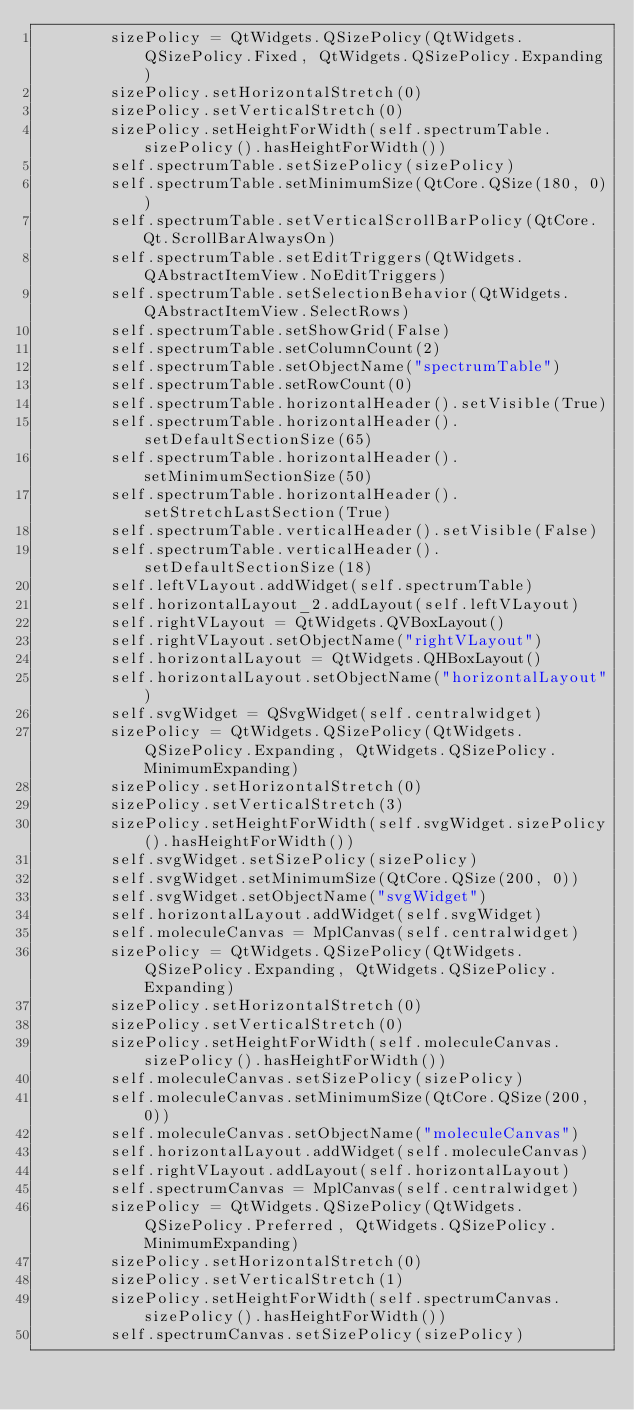Convert code to text. <code><loc_0><loc_0><loc_500><loc_500><_Python_>        sizePolicy = QtWidgets.QSizePolicy(QtWidgets.QSizePolicy.Fixed, QtWidgets.QSizePolicy.Expanding)
        sizePolicy.setHorizontalStretch(0)
        sizePolicy.setVerticalStretch(0)
        sizePolicy.setHeightForWidth(self.spectrumTable.sizePolicy().hasHeightForWidth())
        self.spectrumTable.setSizePolicy(sizePolicy)
        self.spectrumTable.setMinimumSize(QtCore.QSize(180, 0))
        self.spectrumTable.setVerticalScrollBarPolicy(QtCore.Qt.ScrollBarAlwaysOn)
        self.spectrumTable.setEditTriggers(QtWidgets.QAbstractItemView.NoEditTriggers)
        self.spectrumTable.setSelectionBehavior(QtWidgets.QAbstractItemView.SelectRows)
        self.spectrumTable.setShowGrid(False)
        self.spectrumTable.setColumnCount(2)
        self.spectrumTable.setObjectName("spectrumTable")
        self.spectrumTable.setRowCount(0)
        self.spectrumTable.horizontalHeader().setVisible(True)
        self.spectrumTable.horizontalHeader().setDefaultSectionSize(65)
        self.spectrumTable.horizontalHeader().setMinimumSectionSize(50)
        self.spectrumTable.horizontalHeader().setStretchLastSection(True)
        self.spectrumTable.verticalHeader().setVisible(False)
        self.spectrumTable.verticalHeader().setDefaultSectionSize(18)
        self.leftVLayout.addWidget(self.spectrumTable)
        self.horizontalLayout_2.addLayout(self.leftVLayout)
        self.rightVLayout = QtWidgets.QVBoxLayout()
        self.rightVLayout.setObjectName("rightVLayout")
        self.horizontalLayout = QtWidgets.QHBoxLayout()
        self.horizontalLayout.setObjectName("horizontalLayout")
        self.svgWidget = QSvgWidget(self.centralwidget)
        sizePolicy = QtWidgets.QSizePolicy(QtWidgets.QSizePolicy.Expanding, QtWidgets.QSizePolicy.MinimumExpanding)
        sizePolicy.setHorizontalStretch(0)
        sizePolicy.setVerticalStretch(3)
        sizePolicy.setHeightForWidth(self.svgWidget.sizePolicy().hasHeightForWidth())
        self.svgWidget.setSizePolicy(sizePolicy)
        self.svgWidget.setMinimumSize(QtCore.QSize(200, 0))
        self.svgWidget.setObjectName("svgWidget")
        self.horizontalLayout.addWidget(self.svgWidget)
        self.moleculeCanvas = MplCanvas(self.centralwidget)
        sizePolicy = QtWidgets.QSizePolicy(QtWidgets.QSizePolicy.Expanding, QtWidgets.QSizePolicy.Expanding)
        sizePolicy.setHorizontalStretch(0)
        sizePolicy.setVerticalStretch(0)
        sizePolicy.setHeightForWidth(self.moleculeCanvas.sizePolicy().hasHeightForWidth())
        self.moleculeCanvas.setSizePolicy(sizePolicy)
        self.moleculeCanvas.setMinimumSize(QtCore.QSize(200, 0))
        self.moleculeCanvas.setObjectName("moleculeCanvas")
        self.horizontalLayout.addWidget(self.moleculeCanvas)
        self.rightVLayout.addLayout(self.horizontalLayout)
        self.spectrumCanvas = MplCanvas(self.centralwidget)
        sizePolicy = QtWidgets.QSizePolicy(QtWidgets.QSizePolicy.Preferred, QtWidgets.QSizePolicy.MinimumExpanding)
        sizePolicy.setHorizontalStretch(0)
        sizePolicy.setVerticalStretch(1)
        sizePolicy.setHeightForWidth(self.spectrumCanvas.sizePolicy().hasHeightForWidth())
        self.spectrumCanvas.setSizePolicy(sizePolicy)</code> 